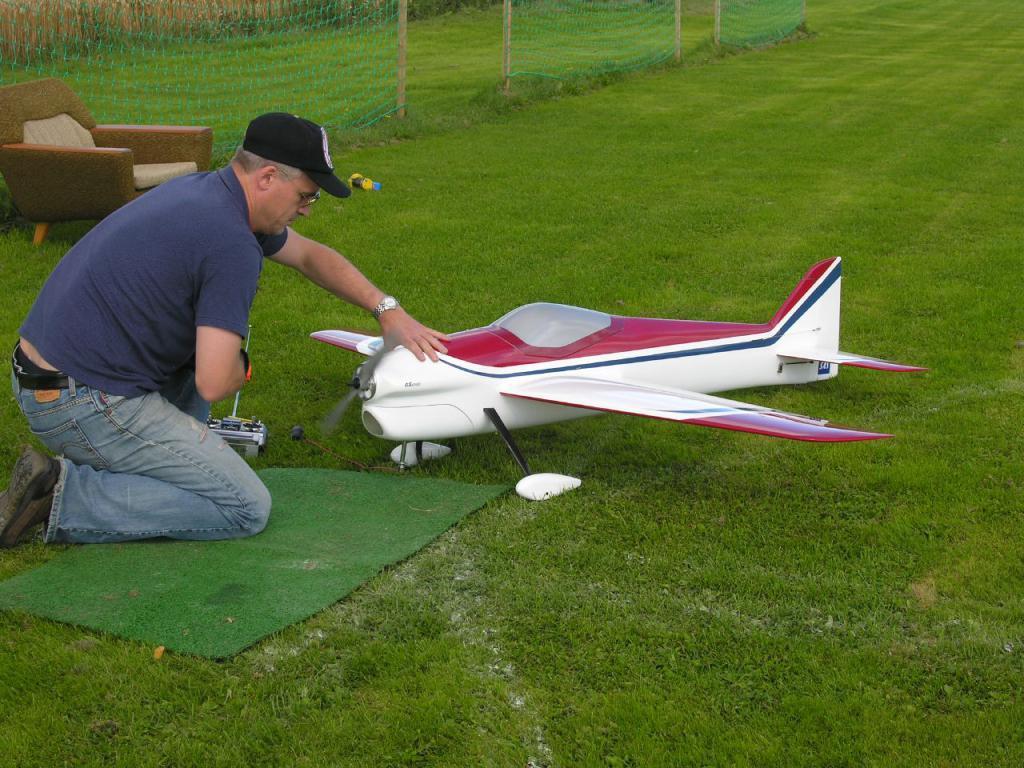Could you give a brief overview of what you see in this image? In this image there is a remote controller and an airplane on the grass, a person sitting on his knees, wire fence, chair. 